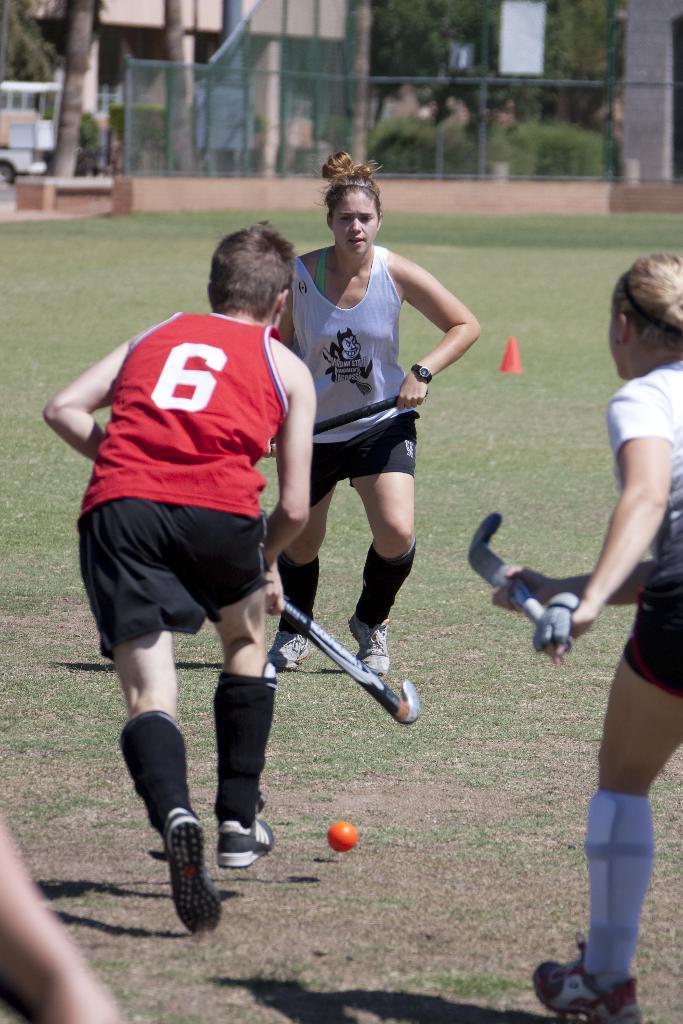Please provide a concise description of this image. In this image we can see a group of people holding sticks are standing on the grass field. In the foreground we can see a ball. In the background, we can see a cone, fence, a group of trees, building and a pillar. On the left side of the image we can see a vehicle parked on the ground. 